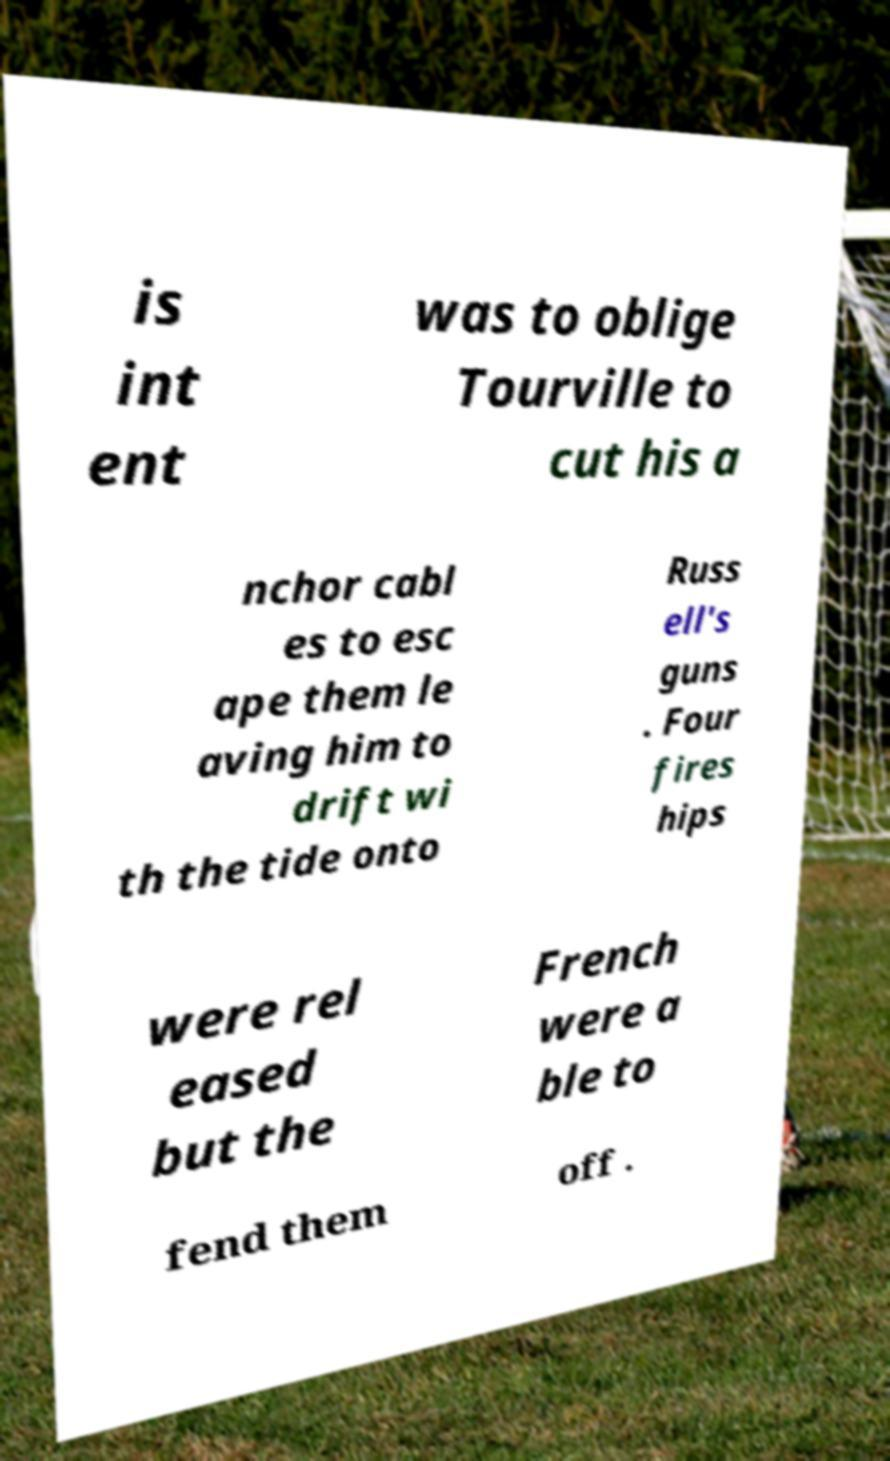I need the written content from this picture converted into text. Can you do that? is int ent was to oblige Tourville to cut his a nchor cabl es to esc ape them le aving him to drift wi th the tide onto Russ ell's guns . Four fires hips were rel eased but the French were a ble to fend them off . 